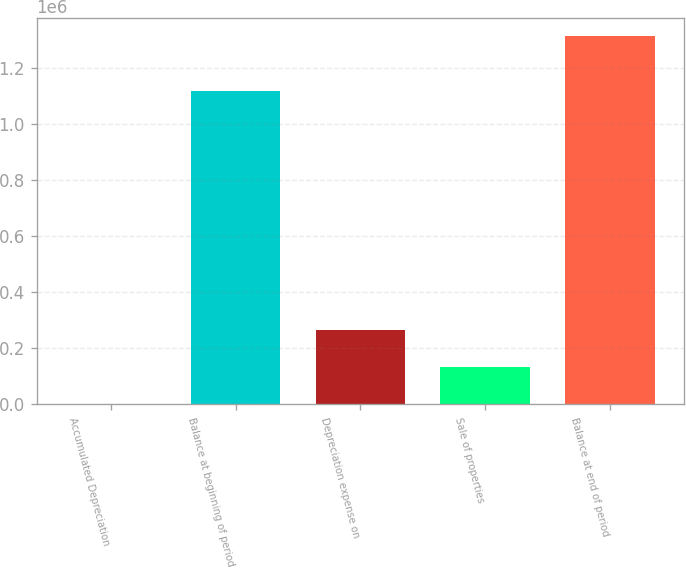Convert chart. <chart><loc_0><loc_0><loc_500><loc_500><bar_chart><fcel>Accumulated Depreciation<fcel>Balance at beginning of period<fcel>Depreciation expense on<fcel>Sale of properties<fcel>Balance at end of period<nl><fcel>2015<fcel>1.12024e+06<fcel>264680<fcel>133347<fcel>1.31534e+06<nl></chart> 